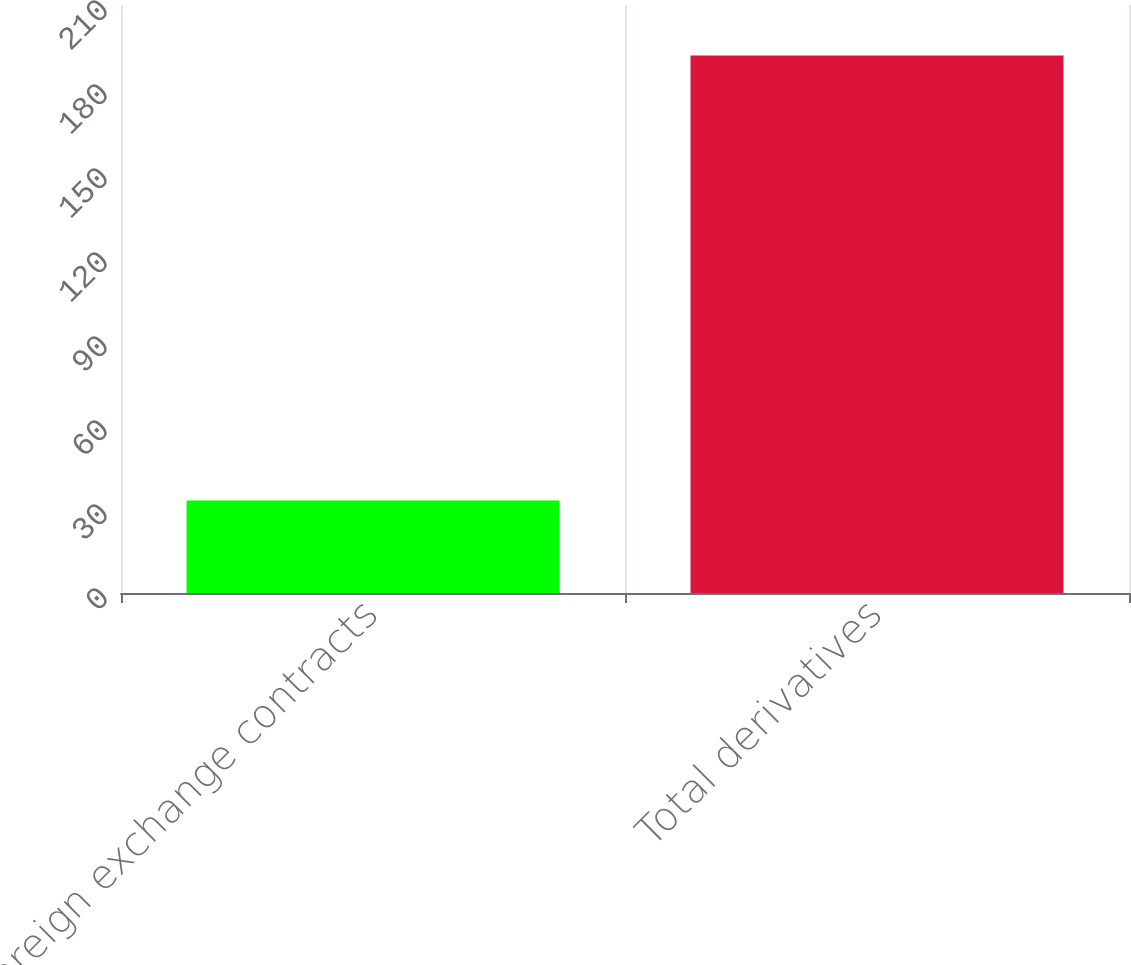Convert chart to OTSL. <chart><loc_0><loc_0><loc_500><loc_500><bar_chart><fcel>Foreign exchange contracts<fcel>Total derivatives<nl><fcel>33<fcel>192<nl></chart> 